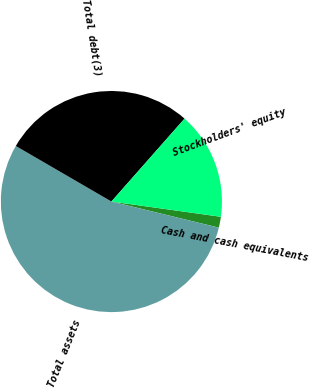<chart> <loc_0><loc_0><loc_500><loc_500><pie_chart><fcel>Cash and cash equivalents<fcel>Total assets<fcel>Total debt(3)<fcel>Stockholders' equity<nl><fcel>1.59%<fcel>54.58%<fcel>28.13%<fcel>15.7%<nl></chart> 